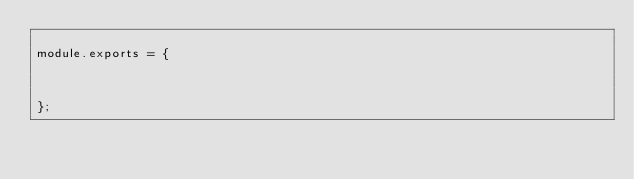<code> <loc_0><loc_0><loc_500><loc_500><_JavaScript_>
module.exports = {

	

};
</code> 